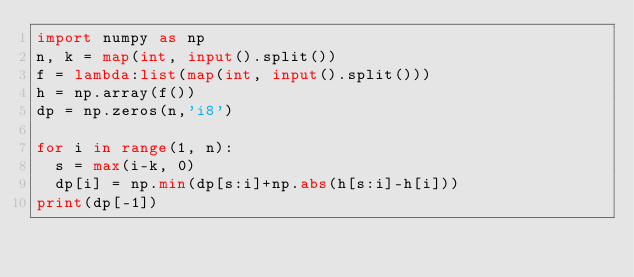<code> <loc_0><loc_0><loc_500><loc_500><_Python_>import numpy as np
n, k = map(int, input().split())
f = lambda:list(map(int, input().split()))
h = np.array(f())
dp = np.zeros(n,'i8')

for i in range(1, n):
  s = max(i-k, 0)
  dp[i] = np.min(dp[s:i]+np.abs(h[s:i]-h[i]))
print(dp[-1])</code> 